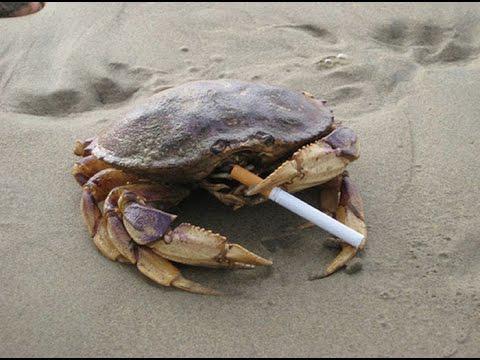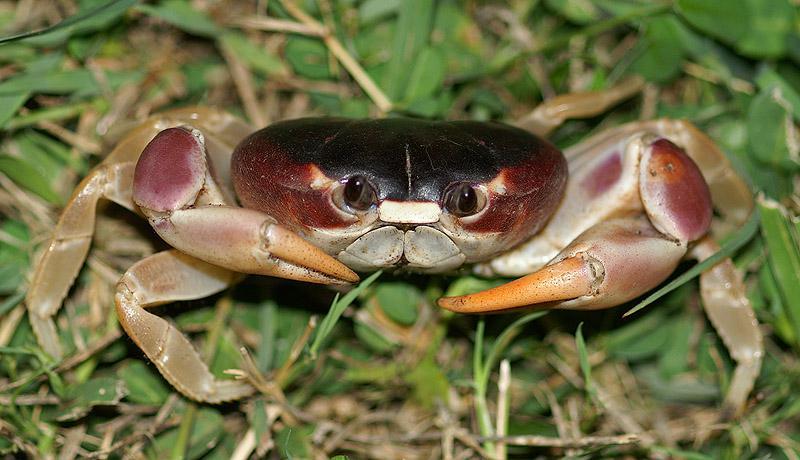The first image is the image on the left, the second image is the image on the right. Given the left and right images, does the statement "Exactly one crab's left claw is higher than its right." hold true? Answer yes or no. Yes. The first image is the image on the left, the second image is the image on the right. Given the left and right images, does the statement "The crab in each of the images is positioned on a sandy sediment." hold true? Answer yes or no. No. 